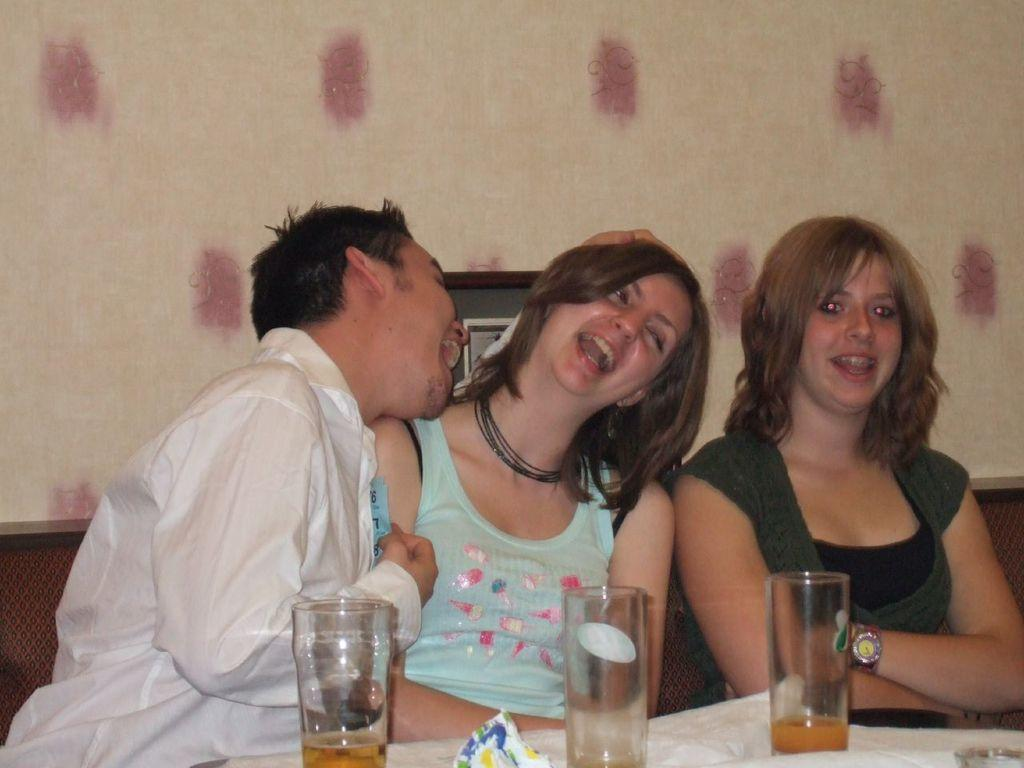What objects are on the table in the image? There are glasses on the table in the image. What are the persons in the image doing? The persons are sitting and smiling in the image. What can be seen in the background of the image? There is a wall in the background of the image. What type of print can be seen on the wall in the image? There is no print visible on the wall in the image; only the wall itself is present. Can you tell me how many brushes are being used by the persons in the image? There are no brushes present in the image; the persons are sitting and smiling without any visible tools or objects. 